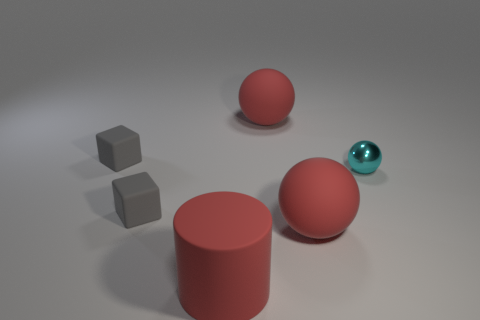Subtract all cyan cylinders. Subtract all cyan cubes. How many cylinders are left? 1 Add 4 tiny matte blocks. How many objects exist? 10 Subtract all cubes. How many objects are left? 4 Add 3 big matte things. How many big matte things exist? 6 Subtract 0 gray balls. How many objects are left? 6 Subtract all small gray rubber objects. Subtract all big red balls. How many objects are left? 2 Add 1 red matte balls. How many red matte balls are left? 3 